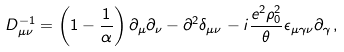<formula> <loc_0><loc_0><loc_500><loc_500>D _ { \mu \nu } ^ { - 1 } = \left ( 1 - \frac { 1 } { \alpha } \right ) \partial _ { \mu } \partial _ { \nu } - \partial ^ { 2 } \delta _ { \mu \nu } - i \frac { e ^ { 2 } \rho _ { 0 } ^ { 2 } } { \theta } \epsilon _ { \mu \gamma \nu } \partial _ { \gamma } \, ,</formula> 